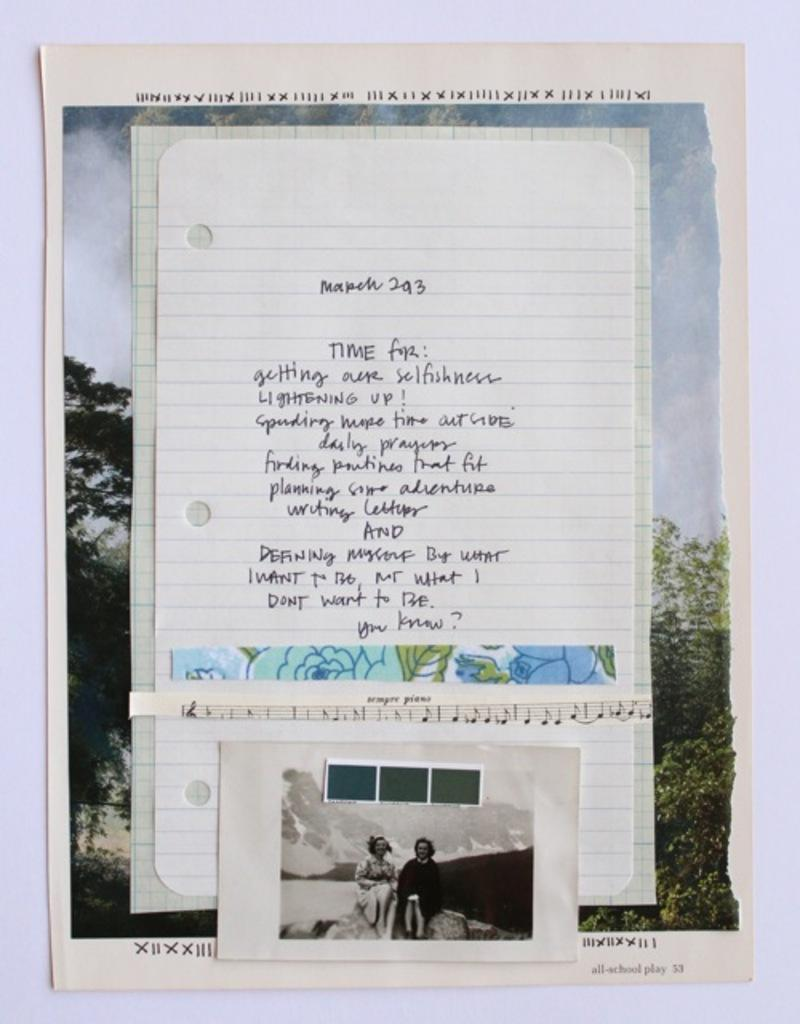<image>
Write a terse but informative summary of the picture. A collection of papers, one of which is marked March 293. 